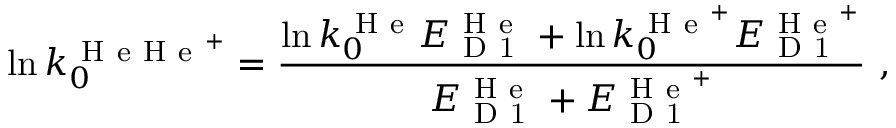Convert formula to latex. <formula><loc_0><loc_0><loc_500><loc_500>\ln k _ { 0 } ^ { H e H e ^ { + } } = \frac { \ln k _ { 0 } ^ { H e } E _ { D 1 } ^ { H e } + \ln k _ { 0 } ^ { H e ^ { + } } E _ { D 1 } ^ { H e ^ { + } } } { E _ { D 1 } ^ { H e } + E _ { D 1 } ^ { H e ^ { + } } } \ ,</formula> 